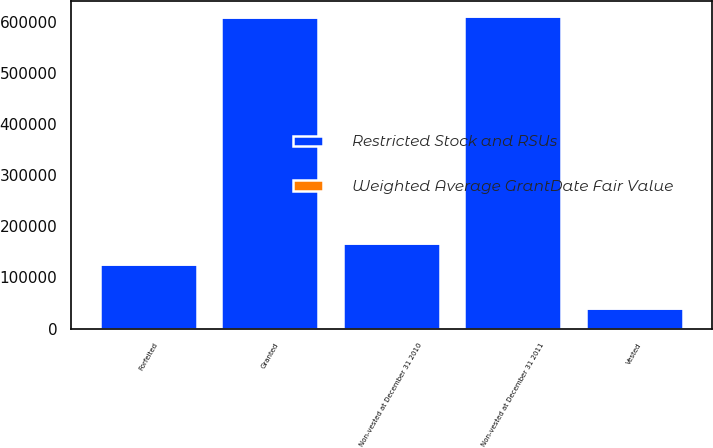<chart> <loc_0><loc_0><loc_500><loc_500><stacked_bar_chart><ecel><fcel>Non-vested at December 31 2010<fcel>Granted<fcel>Vested<fcel>Forfeited<fcel>Non-vested at December 31 2011<nl><fcel>Restricted Stock and RSUs<fcel>168221<fcel>609743<fcel>39844<fcel>127169<fcel>610951<nl><fcel>Weighted Average GrantDate Fair Value<fcel>22.53<fcel>29.77<fcel>23.69<fcel>26.53<fcel>28.85<nl></chart> 